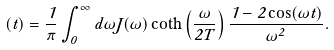<formula> <loc_0><loc_0><loc_500><loc_500>\Gamma ( t ) = \frac { 1 } { \pi } \int _ { 0 } ^ { \infty } d \omega J ( \omega ) \coth \left ( \frac { \omega } { 2 T } \right ) \frac { 1 - 2 \cos ( \omega t ) } { \omega ^ { 2 } } .</formula> 